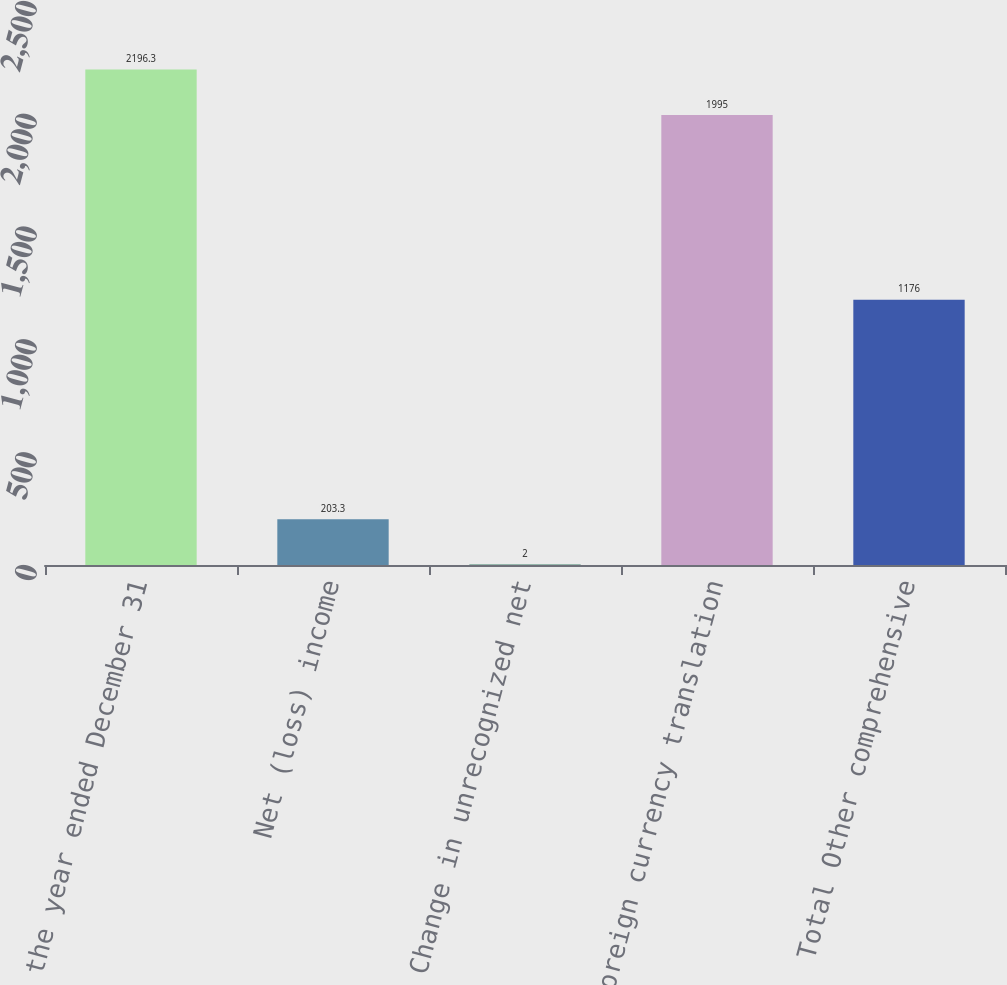<chart> <loc_0><loc_0><loc_500><loc_500><bar_chart><fcel>For the year ended December 31<fcel>Net (loss) income<fcel>Change in unrecognized net<fcel>Foreign currency translation<fcel>Total Other comprehensive<nl><fcel>2196.3<fcel>203.3<fcel>2<fcel>1995<fcel>1176<nl></chart> 